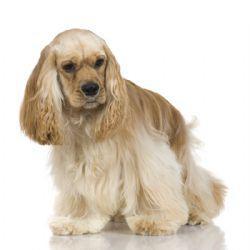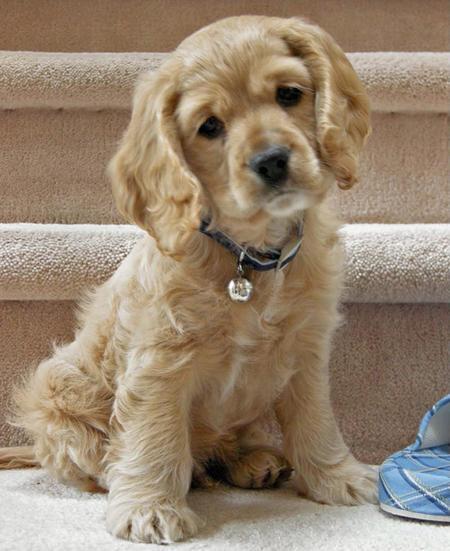The first image is the image on the left, the second image is the image on the right. Analyze the images presented: Is the assertion "The dog in the image on the left is outside." valid? Answer yes or no. No. The first image is the image on the left, the second image is the image on the right. Considering the images on both sides, is "One image shows a blonde spaniel with a metal tag on its collar and its head cocked to the left." valid? Answer yes or no. Yes. 